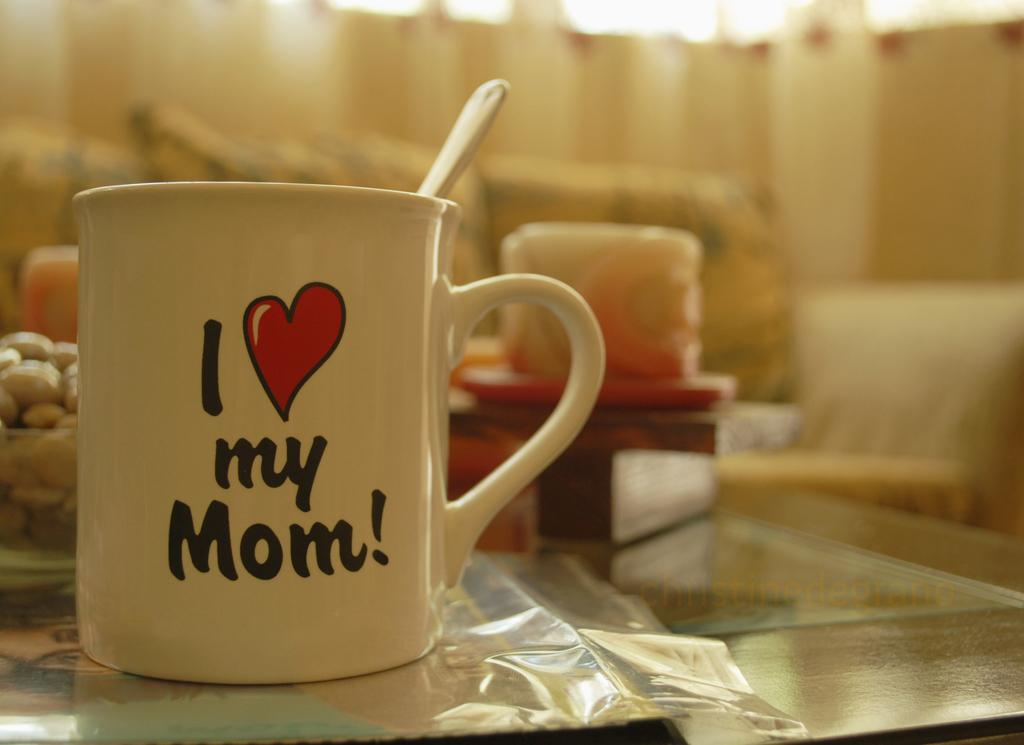Provide a one-sentence caption for the provided image. A mug on a living room table that says I love my mom. 